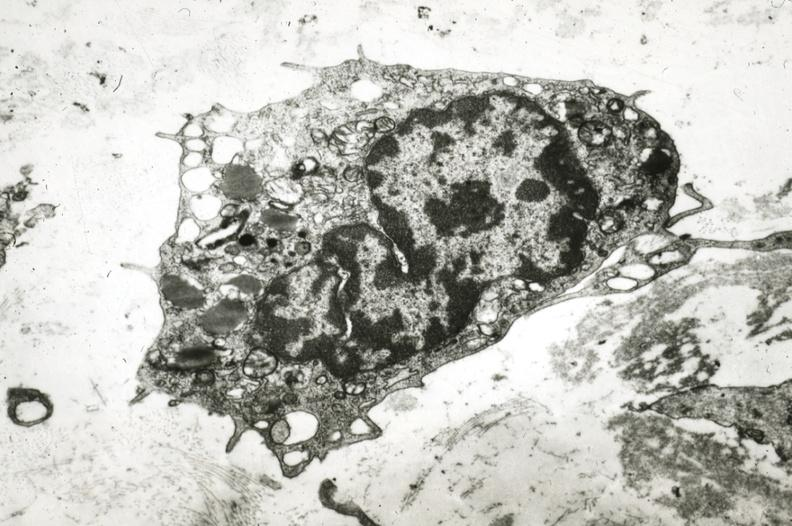s vasculature present?
Answer the question using a single word or phrase. Yes 